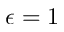<formula> <loc_0><loc_0><loc_500><loc_500>\epsilon = 1</formula> 